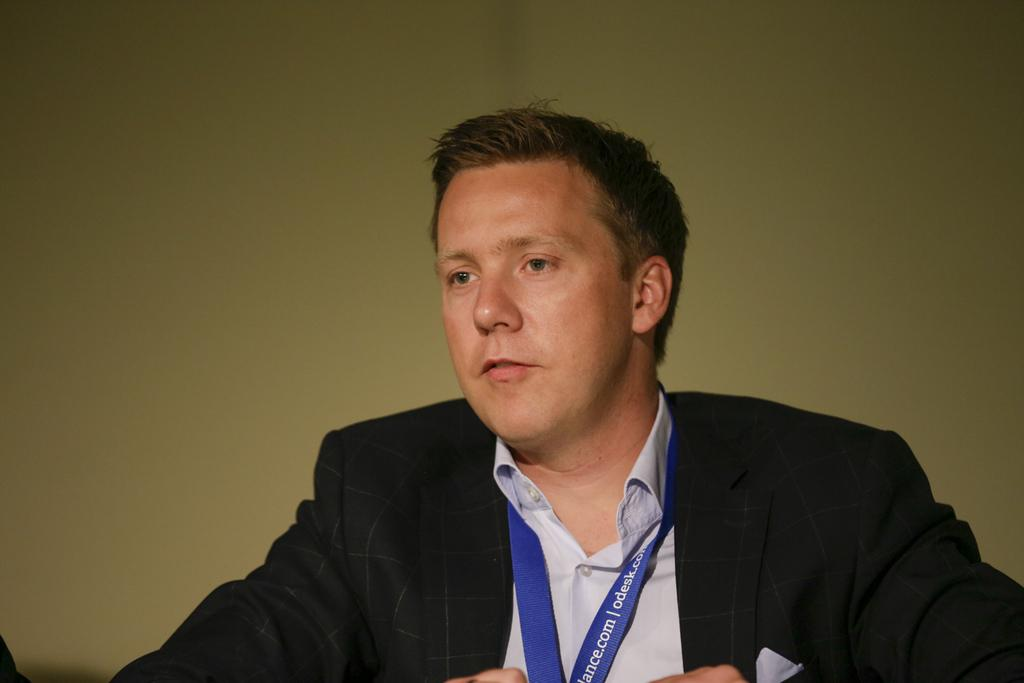What is present in the image that serves as a background or barrier? There is a wall in the image. Who is present in the image? There is a man in the image. What is the man wearing in the image? The man is wearing a black jacket. What type of stitch is the man using to repair the pipe in the image? There is no pipe or stitching activity present in the image; it only features a man wearing a black jacket in front of a wall. 